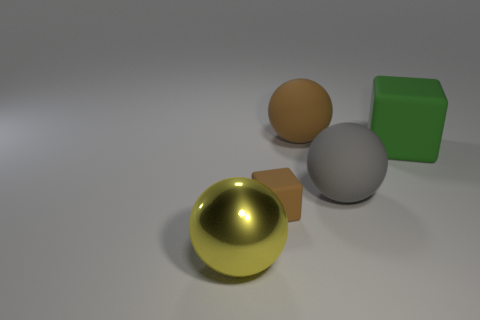What is the shape of the brown object that is left of the rubber ball that is behind the large gray rubber ball?
Your response must be concise. Cube. What number of big gray balls are right of the big sphere to the right of the big brown rubber sphere?
Offer a terse response. 0. There is a ball that is in front of the large green matte thing and to the left of the gray thing; what is its material?
Give a very brief answer. Metal. What shape is the gray object that is the same size as the yellow object?
Offer a terse response. Sphere. What color is the matte block behind the brown rubber thing that is in front of the large thing behind the large green matte object?
Offer a terse response. Green. How many objects are matte objects that are on the left side of the brown ball or big brown balls?
Offer a terse response. 2. What material is the green thing that is the same size as the brown rubber ball?
Make the answer very short. Rubber. The brown object behind the large matte cube right of the sphere behind the green rubber thing is made of what material?
Keep it short and to the point. Rubber. What color is the small thing?
Offer a terse response. Brown. How many big things are yellow metal objects or gray balls?
Provide a short and direct response. 2. 